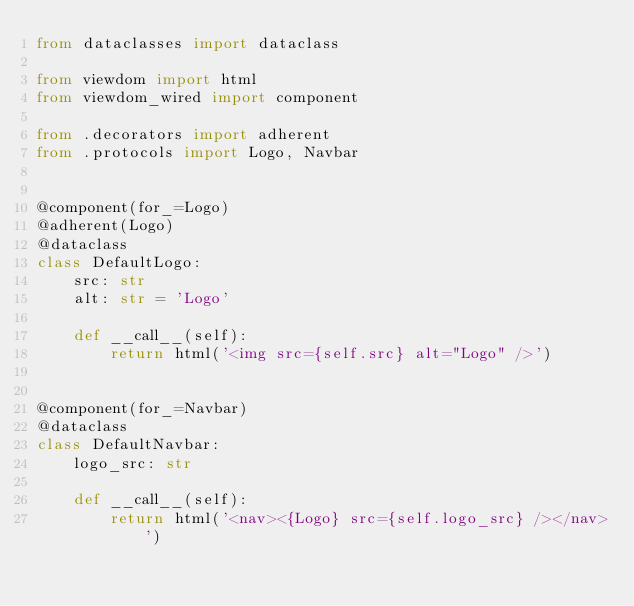<code> <loc_0><loc_0><loc_500><loc_500><_Python_>from dataclasses import dataclass

from viewdom import html
from viewdom_wired import component

from .decorators import adherent
from .protocols import Logo, Navbar


@component(for_=Logo)
@adherent(Logo)
@dataclass
class DefaultLogo:
    src: str
    alt: str = 'Logo'

    def __call__(self):
        return html('<img src={self.src} alt="Logo" />')


@component(for_=Navbar)
@dataclass
class DefaultNavbar:
    logo_src: str

    def __call__(self):
        return html('<nav><{Logo} src={self.logo_src} /></nav>')
</code> 